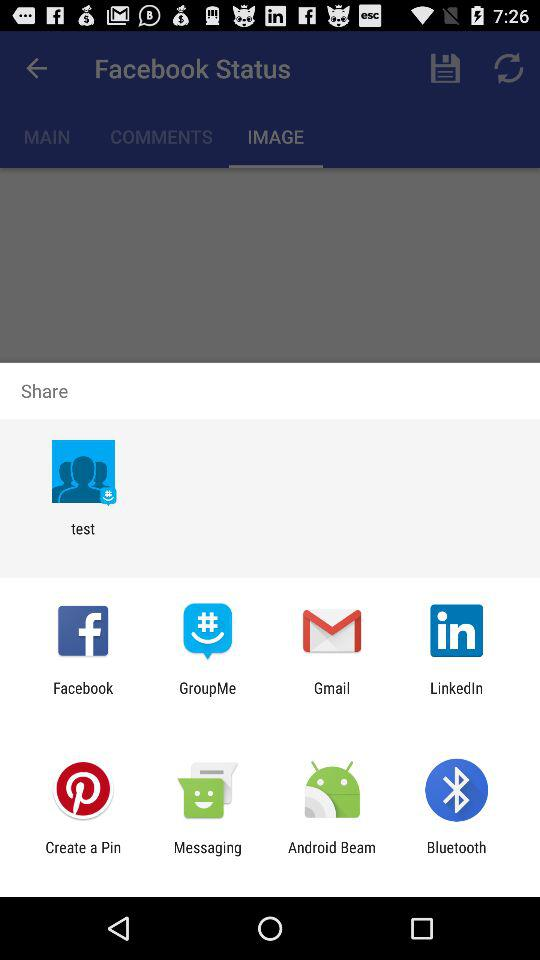Which tab is selected? The selected tab is "IMAGE". 